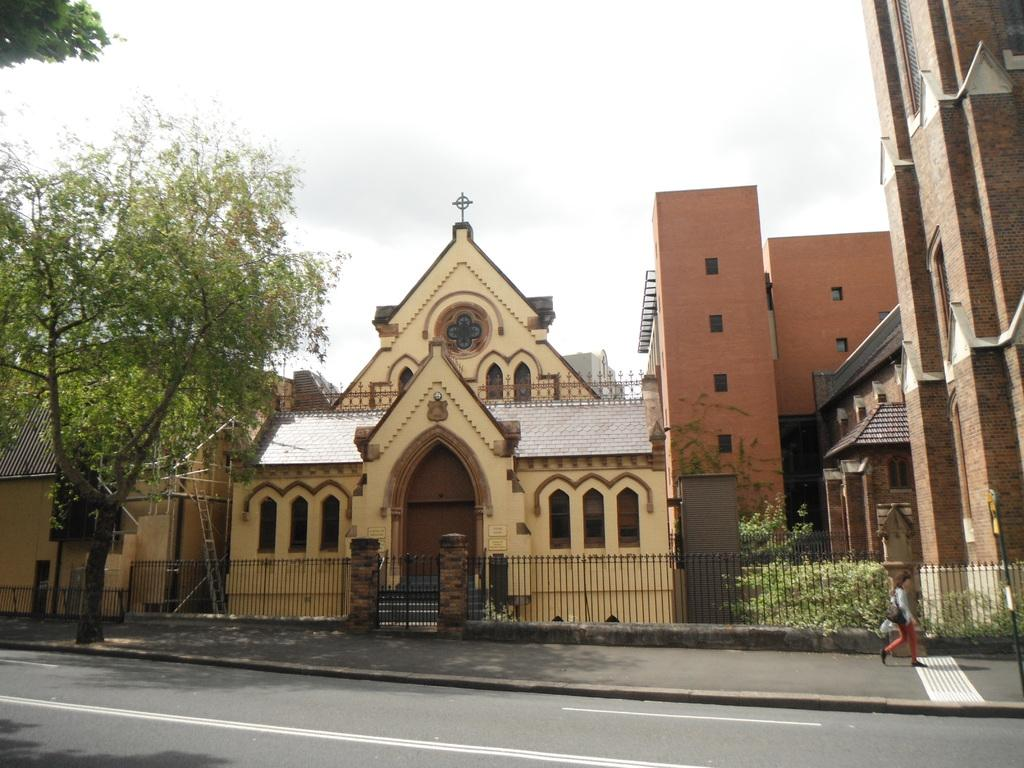What type of structures can be seen in the image? There are many buildings in the image. What natural element is present in the image? There is a tree in the image. What is at the bottom of the image? There is a road at the bottom of the image. What is the woman in the image doing? There is a woman walking to the right in the image. What is visible at the top of the image? There is a sky visible at the top of the image. How many dimes can be seen on the road in the image? There are no dimes present on the road in the image. Can you tell me how the woman is using her credit card in the image? There is no credit card or any indication of its use in the image; the woman is simply walking. 